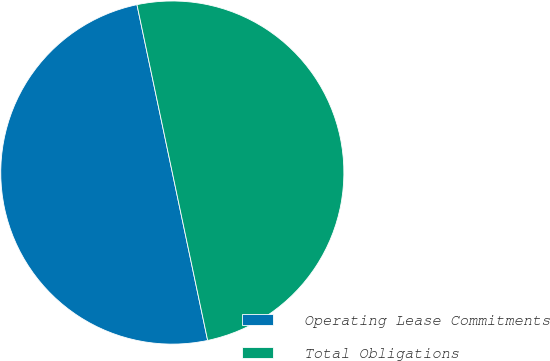Convert chart. <chart><loc_0><loc_0><loc_500><loc_500><pie_chart><fcel>Operating Lease Commitments<fcel>Total Obligations<nl><fcel>50.0%<fcel>50.0%<nl></chart> 